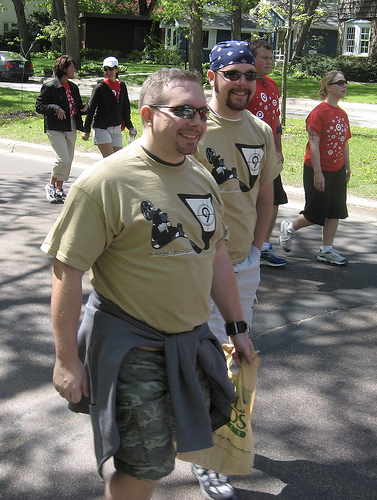<image>
Can you confirm if the man is on the road? Yes. Looking at the image, I can see the man is positioned on top of the road, with the road providing support. Is there a man under the woman? No. The man is not positioned under the woman. The vertical relationship between these objects is different. Where is the window in relation to the grass? Is it next to the grass? No. The window is not positioned next to the grass. They are located in different areas of the scene. Is there a man in front of the woman? No. The man is not in front of the woman. The spatial positioning shows a different relationship between these objects. 